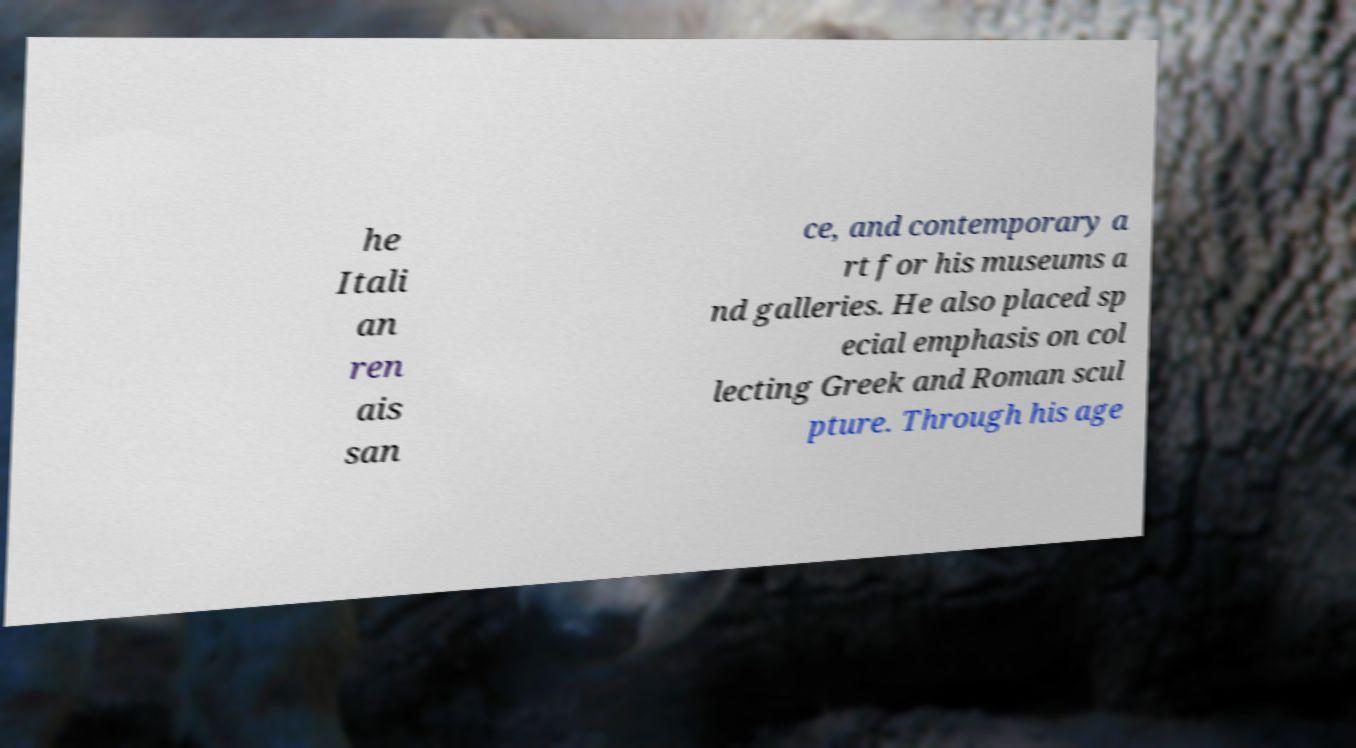Please identify and transcribe the text found in this image. he Itali an ren ais san ce, and contemporary a rt for his museums a nd galleries. He also placed sp ecial emphasis on col lecting Greek and Roman scul pture. Through his age 